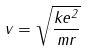Convert formula to latex. <formula><loc_0><loc_0><loc_500><loc_500>v = \sqrt { \frac { k e ^ { 2 } } { m r } }</formula> 